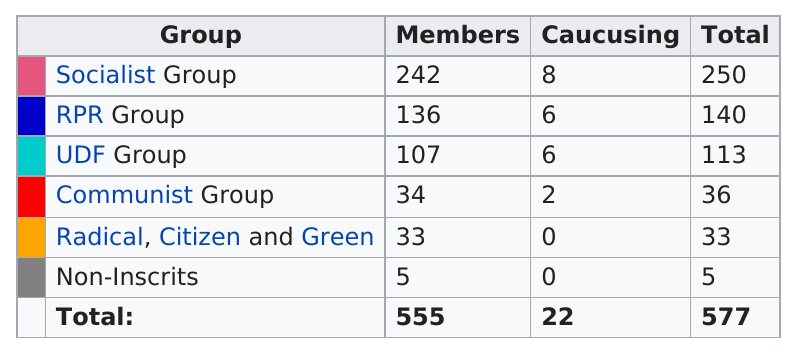Indicate a few pertinent items in this graphic. Of the groups, three had more than 100 members. The RPR Group had over 130 members but only six members who were caucusing. The total number of members between all of the groups is 555. The meeting attendees were divided into groups and caucused to discuss their opinions on the meeting's topics. The groups were formed based on the attendees' political orientation, with the Socialist Group, the RPR Group, and the UDF Group being among those that had more than 5 members. There exists a group with less than 40 members, but at least 2 members caucusing, which is the Communist Group. 